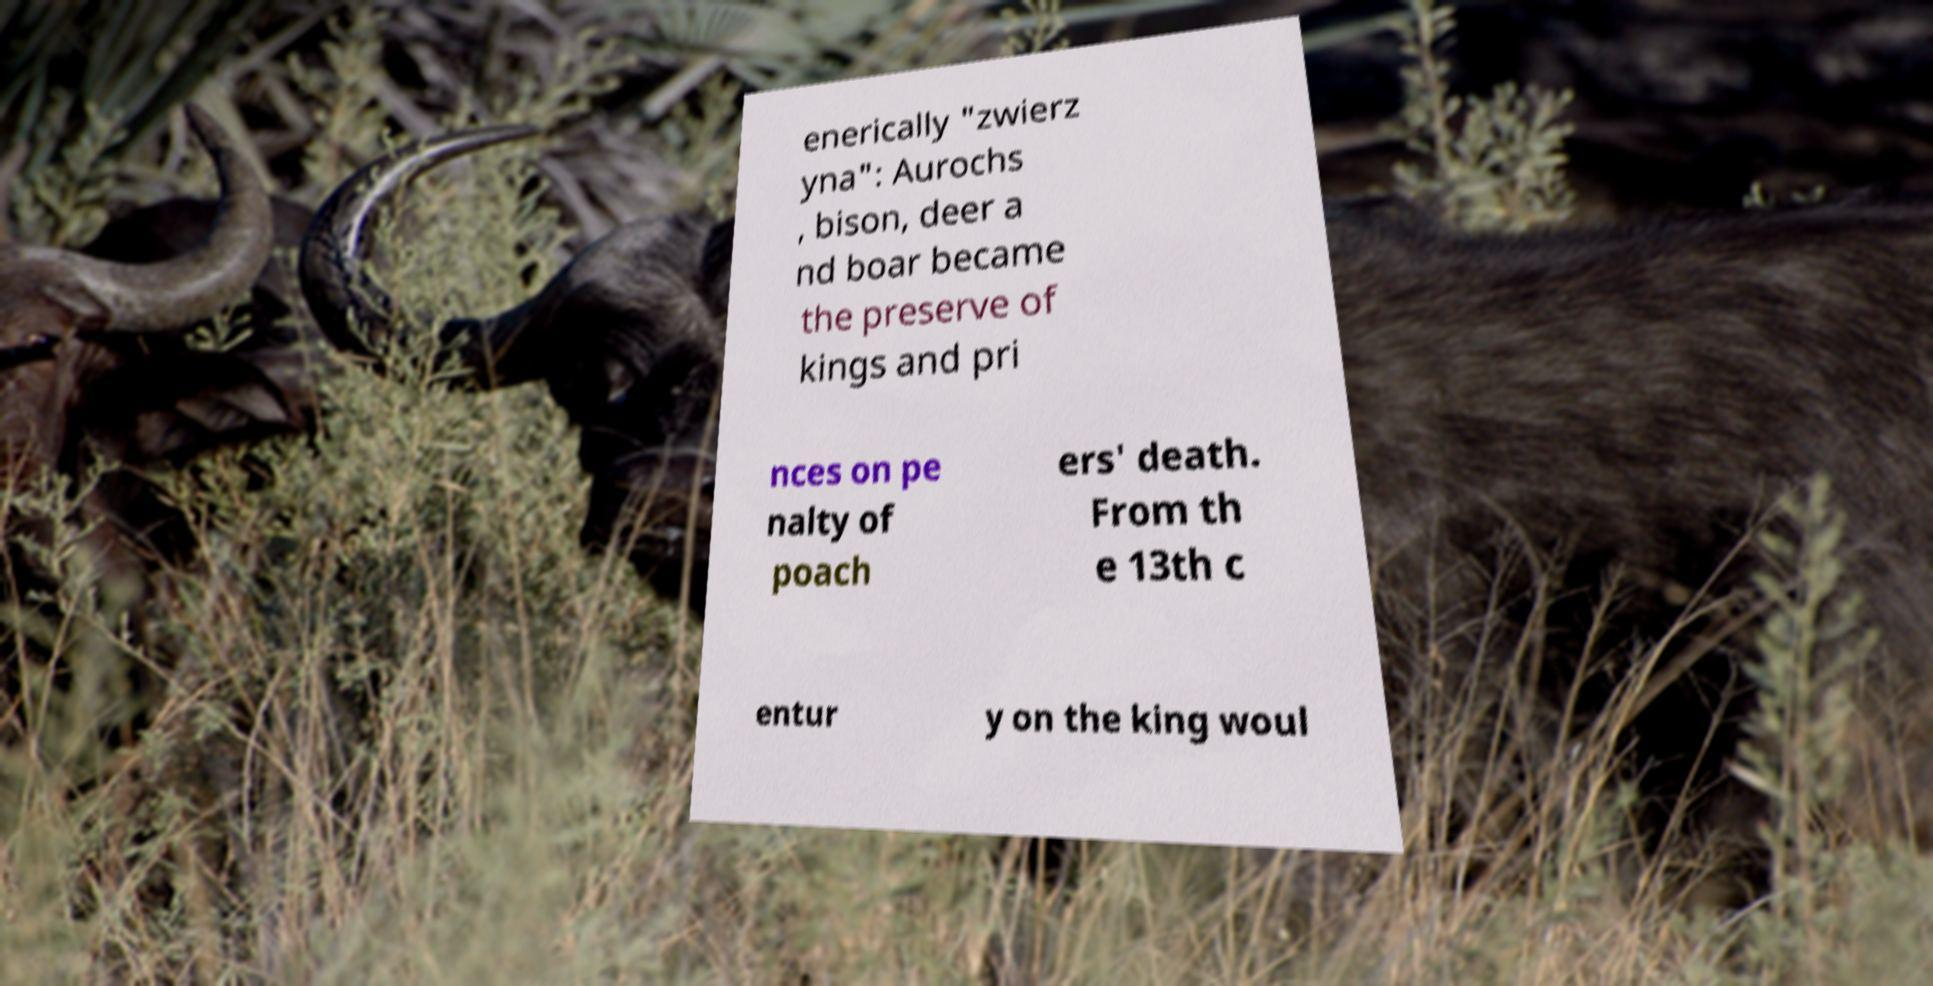I need the written content from this picture converted into text. Can you do that? enerically "zwierz yna": Aurochs , bison, deer a nd boar became the preserve of kings and pri nces on pe nalty of poach ers' death. From th e 13th c entur y on the king woul 